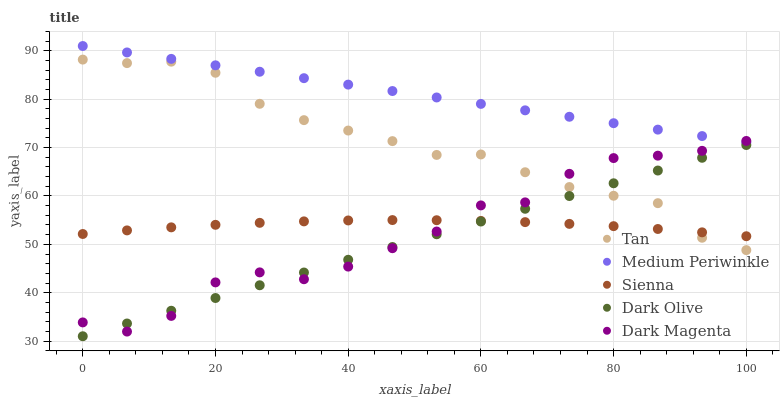Does Dark Olive have the minimum area under the curve?
Answer yes or no. Yes. Does Medium Periwinkle have the maximum area under the curve?
Answer yes or no. Yes. Does Tan have the minimum area under the curve?
Answer yes or no. No. Does Tan have the maximum area under the curve?
Answer yes or no. No. Is Dark Olive the smoothest?
Answer yes or no. Yes. Is Dark Magenta the roughest?
Answer yes or no. Yes. Is Tan the smoothest?
Answer yes or no. No. Is Tan the roughest?
Answer yes or no. No. Does Dark Olive have the lowest value?
Answer yes or no. Yes. Does Tan have the lowest value?
Answer yes or no. No. Does Medium Periwinkle have the highest value?
Answer yes or no. Yes. Does Tan have the highest value?
Answer yes or no. No. Is Dark Olive less than Medium Periwinkle?
Answer yes or no. Yes. Is Medium Periwinkle greater than Sienna?
Answer yes or no. Yes. Does Tan intersect Sienna?
Answer yes or no. Yes. Is Tan less than Sienna?
Answer yes or no. No. Is Tan greater than Sienna?
Answer yes or no. No. Does Dark Olive intersect Medium Periwinkle?
Answer yes or no. No. 